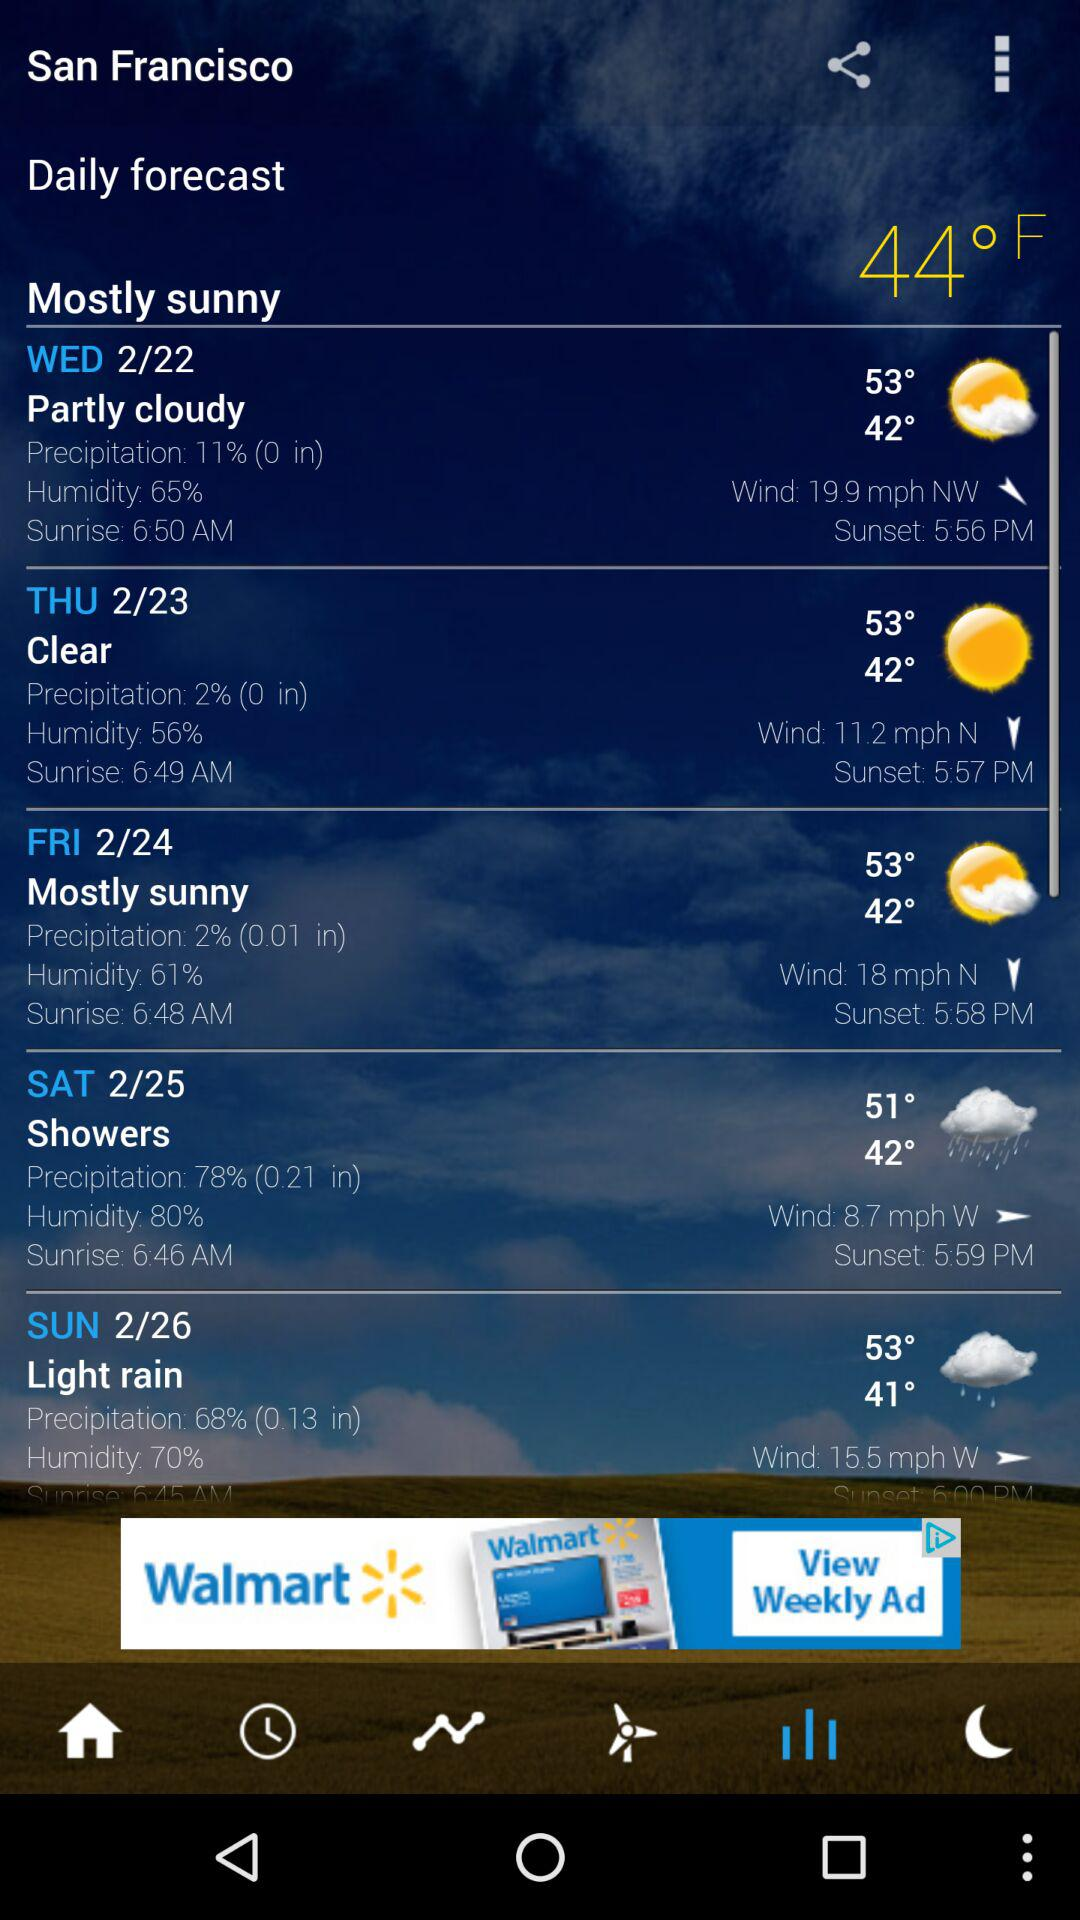What is the unit of wind? The unit of wind is mph. 